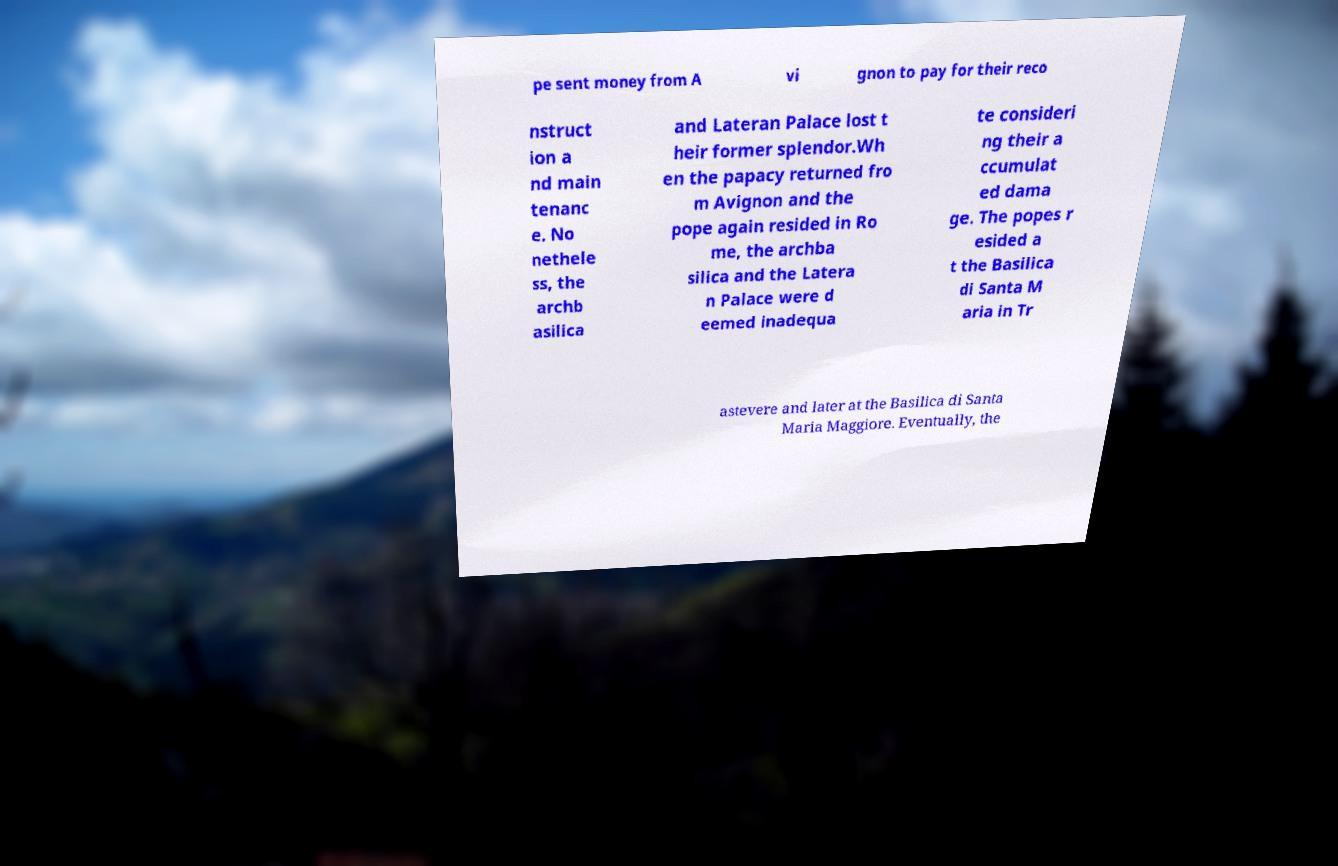For documentation purposes, I need the text within this image transcribed. Could you provide that? pe sent money from A vi gnon to pay for their reco nstruct ion a nd main tenanc e. No nethele ss, the archb asilica and Lateran Palace lost t heir former splendor.Wh en the papacy returned fro m Avignon and the pope again resided in Ro me, the archba silica and the Latera n Palace were d eemed inadequa te consideri ng their a ccumulat ed dama ge. The popes r esided a t the Basilica di Santa M aria in Tr astevere and later at the Basilica di Santa Maria Maggiore. Eventually, the 